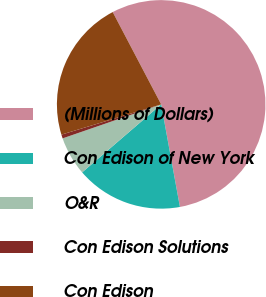Convert chart to OTSL. <chart><loc_0><loc_0><loc_500><loc_500><pie_chart><fcel>(Millions of Dollars)<fcel>Con Edison of New York<fcel>O&R<fcel>Con Edison Solutions<fcel>Con Edison<nl><fcel>54.82%<fcel>16.57%<fcel>6.02%<fcel>0.6%<fcel>21.99%<nl></chart> 